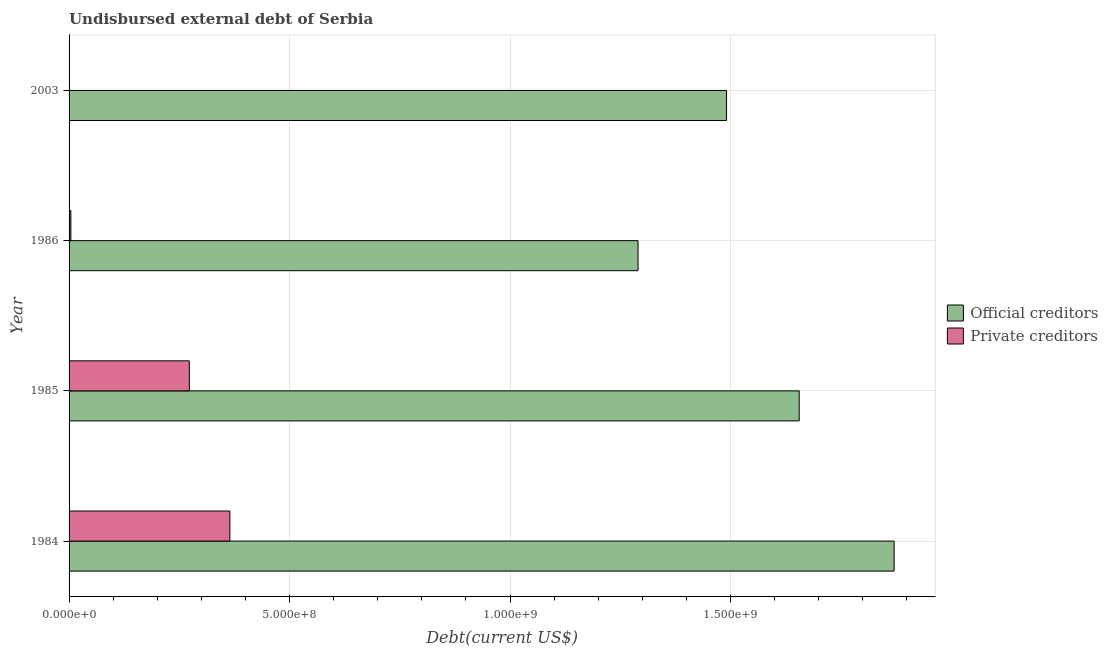Are the number of bars on each tick of the Y-axis equal?
Your answer should be very brief. Yes. What is the label of the 2nd group of bars from the top?
Your answer should be compact. 1986. What is the undisbursed external debt of official creditors in 1986?
Keep it short and to the point. 1.29e+09. Across all years, what is the maximum undisbursed external debt of official creditors?
Provide a short and direct response. 1.87e+09. Across all years, what is the minimum undisbursed external debt of private creditors?
Your answer should be compact. 5.05e+05. In which year was the undisbursed external debt of official creditors minimum?
Your response must be concise. 1986. What is the total undisbursed external debt of private creditors in the graph?
Your answer should be very brief. 6.42e+08. What is the difference between the undisbursed external debt of official creditors in 1984 and that in 1986?
Ensure brevity in your answer.  5.81e+08. What is the difference between the undisbursed external debt of private creditors in 1985 and the undisbursed external debt of official creditors in 2003?
Keep it short and to the point. -1.22e+09. What is the average undisbursed external debt of official creditors per year?
Offer a terse response. 1.58e+09. In the year 1984, what is the difference between the undisbursed external debt of official creditors and undisbursed external debt of private creditors?
Provide a short and direct response. 1.51e+09. In how many years, is the undisbursed external debt of official creditors greater than 1300000000 US$?
Keep it short and to the point. 3. What is the ratio of the undisbursed external debt of private creditors in 1984 to that in 1985?
Offer a terse response. 1.34. What is the difference between the highest and the second highest undisbursed external debt of private creditors?
Provide a succinct answer. 9.20e+07. What is the difference between the highest and the lowest undisbursed external debt of private creditors?
Offer a terse response. 3.64e+08. In how many years, is the undisbursed external debt of private creditors greater than the average undisbursed external debt of private creditors taken over all years?
Provide a short and direct response. 2. What does the 2nd bar from the top in 1985 represents?
Provide a succinct answer. Official creditors. What does the 2nd bar from the bottom in 1986 represents?
Your response must be concise. Private creditors. Are the values on the major ticks of X-axis written in scientific E-notation?
Your response must be concise. Yes. Does the graph contain any zero values?
Provide a succinct answer. No. Does the graph contain grids?
Offer a terse response. Yes. Where does the legend appear in the graph?
Offer a terse response. Center right. How many legend labels are there?
Your answer should be compact. 2. How are the legend labels stacked?
Your response must be concise. Vertical. What is the title of the graph?
Make the answer very short. Undisbursed external debt of Serbia. What is the label or title of the X-axis?
Provide a short and direct response. Debt(current US$). What is the label or title of the Y-axis?
Offer a terse response. Year. What is the Debt(current US$) of Official creditors in 1984?
Your answer should be very brief. 1.87e+09. What is the Debt(current US$) in Private creditors in 1984?
Your response must be concise. 3.65e+08. What is the Debt(current US$) of Official creditors in 1985?
Make the answer very short. 1.66e+09. What is the Debt(current US$) in Private creditors in 1985?
Give a very brief answer. 2.73e+08. What is the Debt(current US$) in Official creditors in 1986?
Your answer should be compact. 1.29e+09. What is the Debt(current US$) in Private creditors in 1986?
Offer a terse response. 4.10e+06. What is the Debt(current US$) in Official creditors in 2003?
Give a very brief answer. 1.49e+09. What is the Debt(current US$) of Private creditors in 2003?
Provide a short and direct response. 5.05e+05. Across all years, what is the maximum Debt(current US$) of Official creditors?
Provide a succinct answer. 1.87e+09. Across all years, what is the maximum Debt(current US$) of Private creditors?
Give a very brief answer. 3.65e+08. Across all years, what is the minimum Debt(current US$) in Official creditors?
Your answer should be compact. 1.29e+09. Across all years, what is the minimum Debt(current US$) of Private creditors?
Provide a short and direct response. 5.05e+05. What is the total Debt(current US$) of Official creditors in the graph?
Make the answer very short. 6.31e+09. What is the total Debt(current US$) of Private creditors in the graph?
Ensure brevity in your answer.  6.42e+08. What is the difference between the Debt(current US$) in Official creditors in 1984 and that in 1985?
Provide a succinct answer. 2.15e+08. What is the difference between the Debt(current US$) of Private creditors in 1984 and that in 1985?
Give a very brief answer. 9.20e+07. What is the difference between the Debt(current US$) in Official creditors in 1984 and that in 1986?
Offer a terse response. 5.81e+08. What is the difference between the Debt(current US$) in Private creditors in 1984 and that in 1986?
Offer a terse response. 3.61e+08. What is the difference between the Debt(current US$) in Official creditors in 1984 and that in 2003?
Keep it short and to the point. 3.80e+08. What is the difference between the Debt(current US$) of Private creditors in 1984 and that in 2003?
Offer a terse response. 3.64e+08. What is the difference between the Debt(current US$) of Official creditors in 1985 and that in 1986?
Keep it short and to the point. 3.65e+08. What is the difference between the Debt(current US$) in Private creditors in 1985 and that in 1986?
Ensure brevity in your answer.  2.69e+08. What is the difference between the Debt(current US$) in Official creditors in 1985 and that in 2003?
Offer a terse response. 1.65e+08. What is the difference between the Debt(current US$) of Private creditors in 1985 and that in 2003?
Your answer should be very brief. 2.72e+08. What is the difference between the Debt(current US$) in Official creditors in 1986 and that in 2003?
Provide a succinct answer. -2.01e+08. What is the difference between the Debt(current US$) in Private creditors in 1986 and that in 2003?
Your answer should be compact. 3.60e+06. What is the difference between the Debt(current US$) of Official creditors in 1984 and the Debt(current US$) of Private creditors in 1985?
Keep it short and to the point. 1.60e+09. What is the difference between the Debt(current US$) in Official creditors in 1984 and the Debt(current US$) in Private creditors in 1986?
Your response must be concise. 1.87e+09. What is the difference between the Debt(current US$) of Official creditors in 1984 and the Debt(current US$) of Private creditors in 2003?
Ensure brevity in your answer.  1.87e+09. What is the difference between the Debt(current US$) in Official creditors in 1985 and the Debt(current US$) in Private creditors in 1986?
Give a very brief answer. 1.65e+09. What is the difference between the Debt(current US$) in Official creditors in 1985 and the Debt(current US$) in Private creditors in 2003?
Your response must be concise. 1.66e+09. What is the difference between the Debt(current US$) in Official creditors in 1986 and the Debt(current US$) in Private creditors in 2003?
Give a very brief answer. 1.29e+09. What is the average Debt(current US$) of Official creditors per year?
Keep it short and to the point. 1.58e+09. What is the average Debt(current US$) in Private creditors per year?
Offer a terse response. 1.60e+08. In the year 1984, what is the difference between the Debt(current US$) in Official creditors and Debt(current US$) in Private creditors?
Your answer should be compact. 1.51e+09. In the year 1985, what is the difference between the Debt(current US$) in Official creditors and Debt(current US$) in Private creditors?
Make the answer very short. 1.38e+09. In the year 1986, what is the difference between the Debt(current US$) of Official creditors and Debt(current US$) of Private creditors?
Keep it short and to the point. 1.29e+09. In the year 2003, what is the difference between the Debt(current US$) in Official creditors and Debt(current US$) in Private creditors?
Your response must be concise. 1.49e+09. What is the ratio of the Debt(current US$) of Official creditors in 1984 to that in 1985?
Give a very brief answer. 1.13. What is the ratio of the Debt(current US$) of Private creditors in 1984 to that in 1985?
Offer a very short reply. 1.34. What is the ratio of the Debt(current US$) in Official creditors in 1984 to that in 1986?
Offer a very short reply. 1.45. What is the ratio of the Debt(current US$) in Private creditors in 1984 to that in 1986?
Your response must be concise. 88.92. What is the ratio of the Debt(current US$) of Official creditors in 1984 to that in 2003?
Your answer should be very brief. 1.25. What is the ratio of the Debt(current US$) of Private creditors in 1984 to that in 2003?
Your response must be concise. 722.08. What is the ratio of the Debt(current US$) of Official creditors in 1985 to that in 1986?
Provide a short and direct response. 1.28. What is the ratio of the Debt(current US$) of Private creditors in 1985 to that in 1986?
Provide a succinct answer. 66.49. What is the ratio of the Debt(current US$) in Official creditors in 1985 to that in 2003?
Provide a succinct answer. 1.11. What is the ratio of the Debt(current US$) in Private creditors in 1985 to that in 2003?
Ensure brevity in your answer.  539.93. What is the ratio of the Debt(current US$) of Official creditors in 1986 to that in 2003?
Provide a succinct answer. 0.87. What is the ratio of the Debt(current US$) in Private creditors in 1986 to that in 2003?
Keep it short and to the point. 8.12. What is the difference between the highest and the second highest Debt(current US$) in Official creditors?
Provide a short and direct response. 2.15e+08. What is the difference between the highest and the second highest Debt(current US$) in Private creditors?
Provide a short and direct response. 9.20e+07. What is the difference between the highest and the lowest Debt(current US$) of Official creditors?
Keep it short and to the point. 5.81e+08. What is the difference between the highest and the lowest Debt(current US$) in Private creditors?
Ensure brevity in your answer.  3.64e+08. 